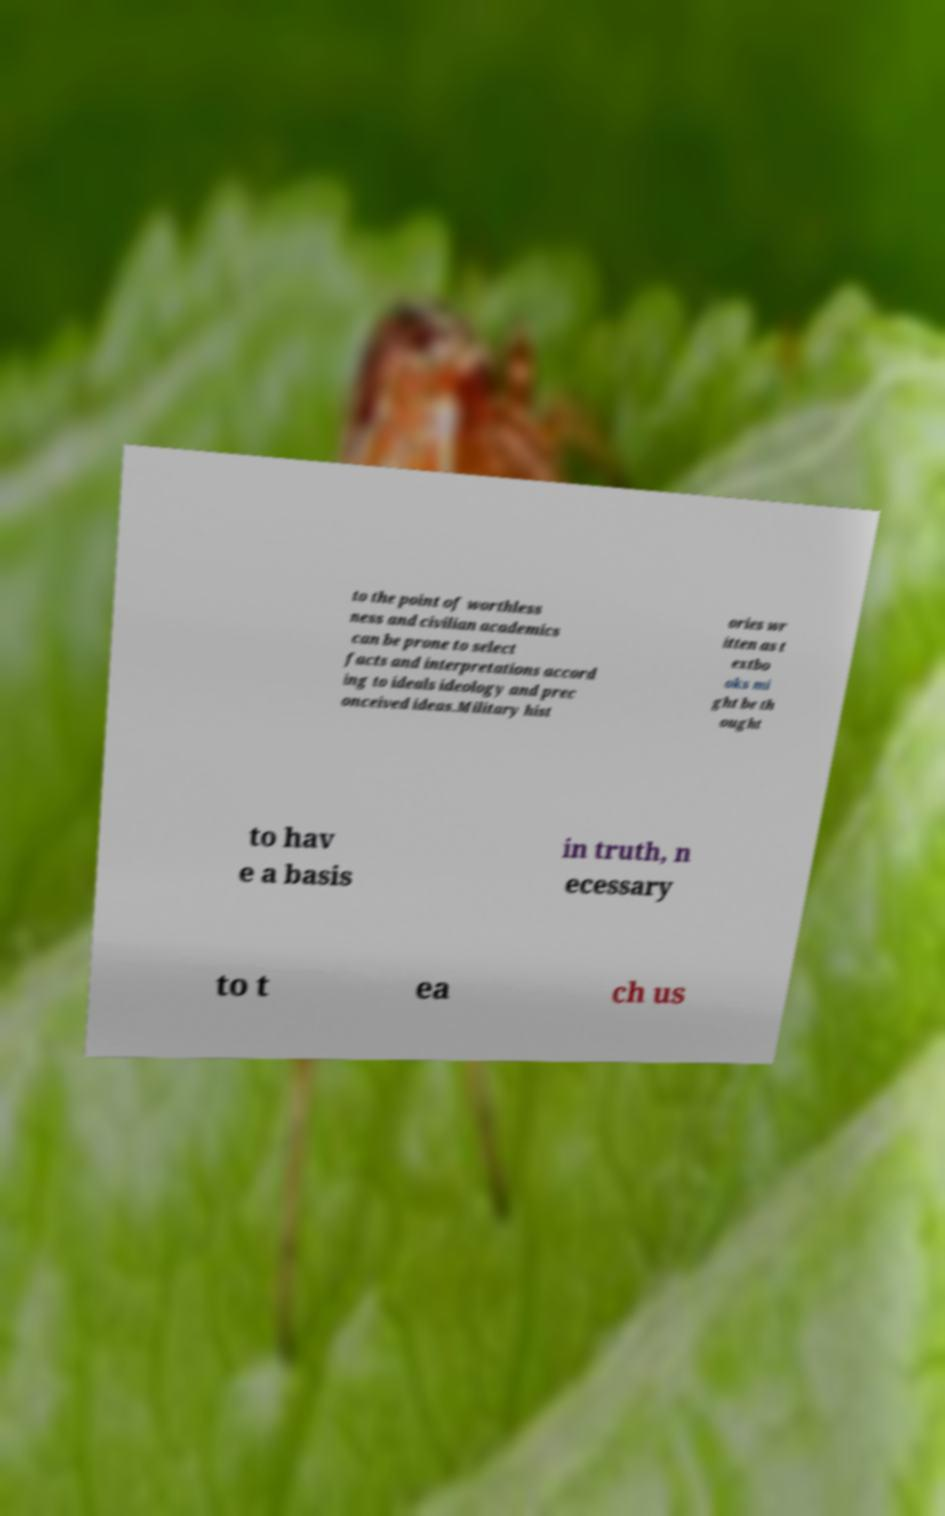Can you read and provide the text displayed in the image?This photo seems to have some interesting text. Can you extract and type it out for me? to the point of worthless ness and civilian academics can be prone to select facts and interpretations accord ing to ideals ideology and prec onceived ideas.Military hist ories wr itten as t extbo oks mi ght be th ought to hav e a basis in truth, n ecessary to t ea ch us 